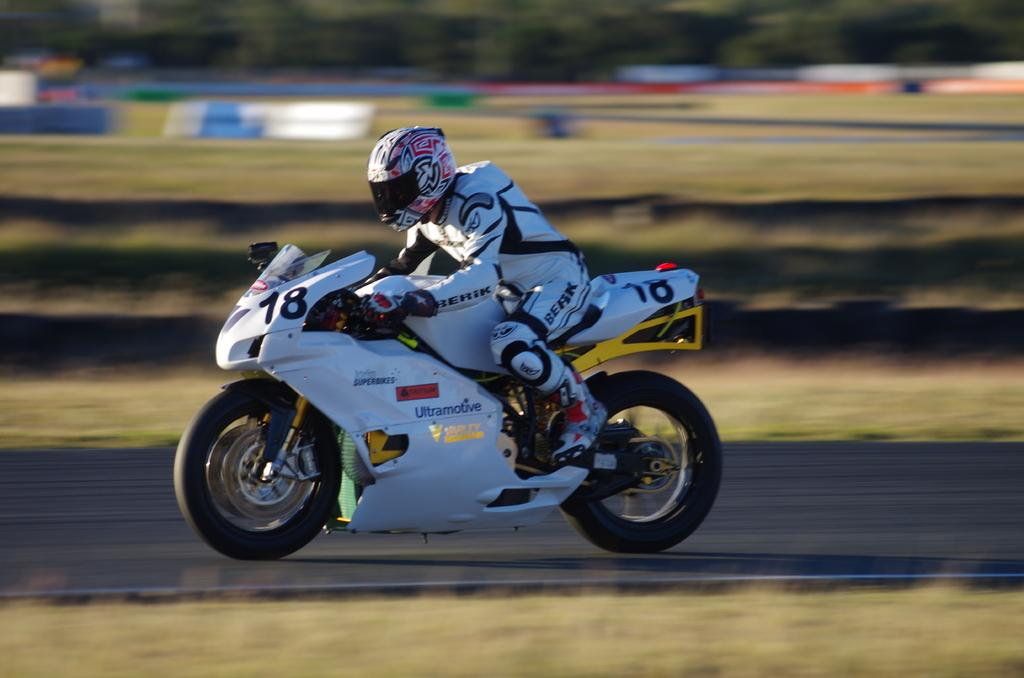What is the main subject of the image? The main subject of the image is a bike. What is the bike doing in the image? The bike is moving on a road. Can you describe the background of the image? The background of the image is blurred. What type of zephyr can be seen blowing in the background of the image? There is no zephyr present in the image. How long does it take for the bike to move a minute in the image? The image is a still photograph, so it does not show the bike moving over time. --- Facts: 1. There is a person holding a camera in the image. 2. The person is standing on a bridge. 3. There is a river visible below the bridge. 4. The sky is visible above the bridge. Absurd Topics: elephant, piano, ocean Conversation: What is the person in the image holding? The person in the image is holding a camera. Where is the person standing in the image? The person is standing on a bridge. What can be seen below the bridge in the image? There is a river visible below the bridge. What is visible above the bridge in the image? The sky is visible above the bridge. Reasoning: Let's think step by step in order to produce the conversation. We start by identifying the main subject of the image, which is the person holding a camera. Next, we describe the location of the person, which is standing on a bridge. Then, we describe the view below and above the bridge, which is a river and the sky, respectively. Absurd Question/Answer: Can you see an elephant playing a piano on the river in the image? There is no elephant or piano present in the image. What type of ocean can be seen in the background of the image? There is no ocean visible in the image; it features a river and a sky. --- Facts: 1. There is a person sitting on a bench in the image. 2. The person is reading a book. 3. There is a tree behind the bench. 4. The ground is visible in the image. Absurd Topics: parrot, volcano, spaceship Conversation: What is the person in the image doing? The person in the image is sitting on a bench and reading a book. What is located behind the bench in the image? There is a tree behind the bench. Can the ground be seen in the image? Yes, the ground is visible in the image. Reasoning: Let's think step by step in order to produce the conversation. We start by identifying the main subject of the image, which is the person sitting on a bench. Next, we describe the action of the person, which is reading a book. Then, we describe the view behind the bench, which is a tree. Finally, we describe the ground, which is visible in the image. Absurd Question/ 